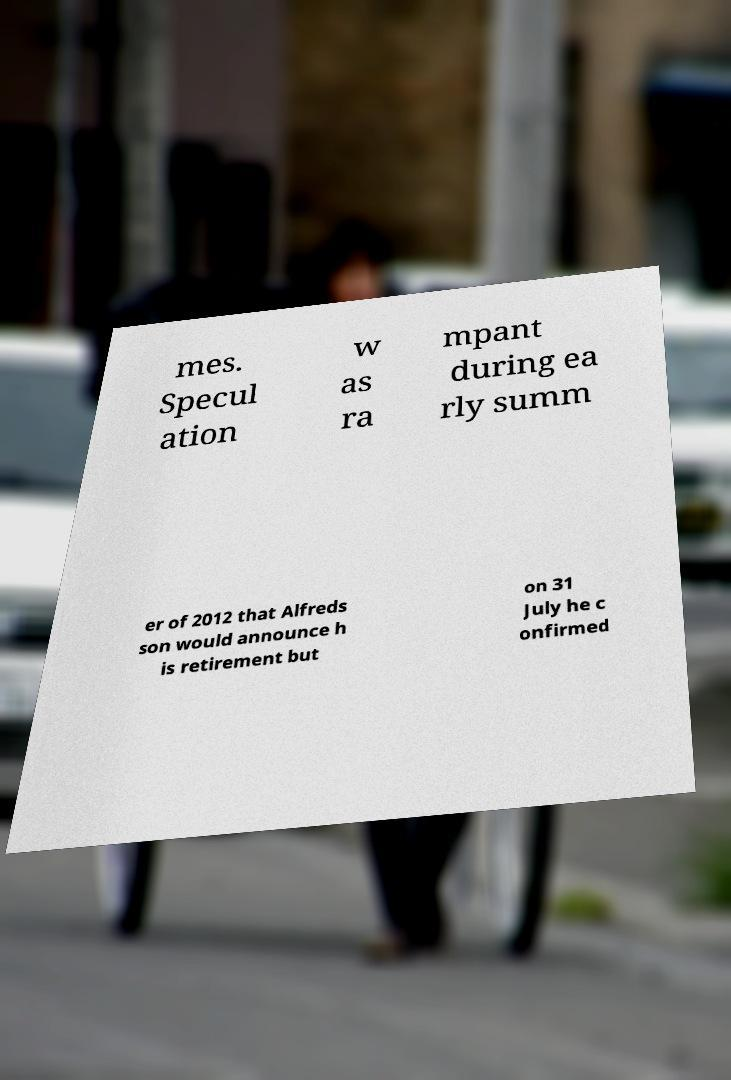Please read and relay the text visible in this image. What does it say? mes. Specul ation w as ra mpant during ea rly summ er of 2012 that Alfreds son would announce h is retirement but on 31 July he c onfirmed 